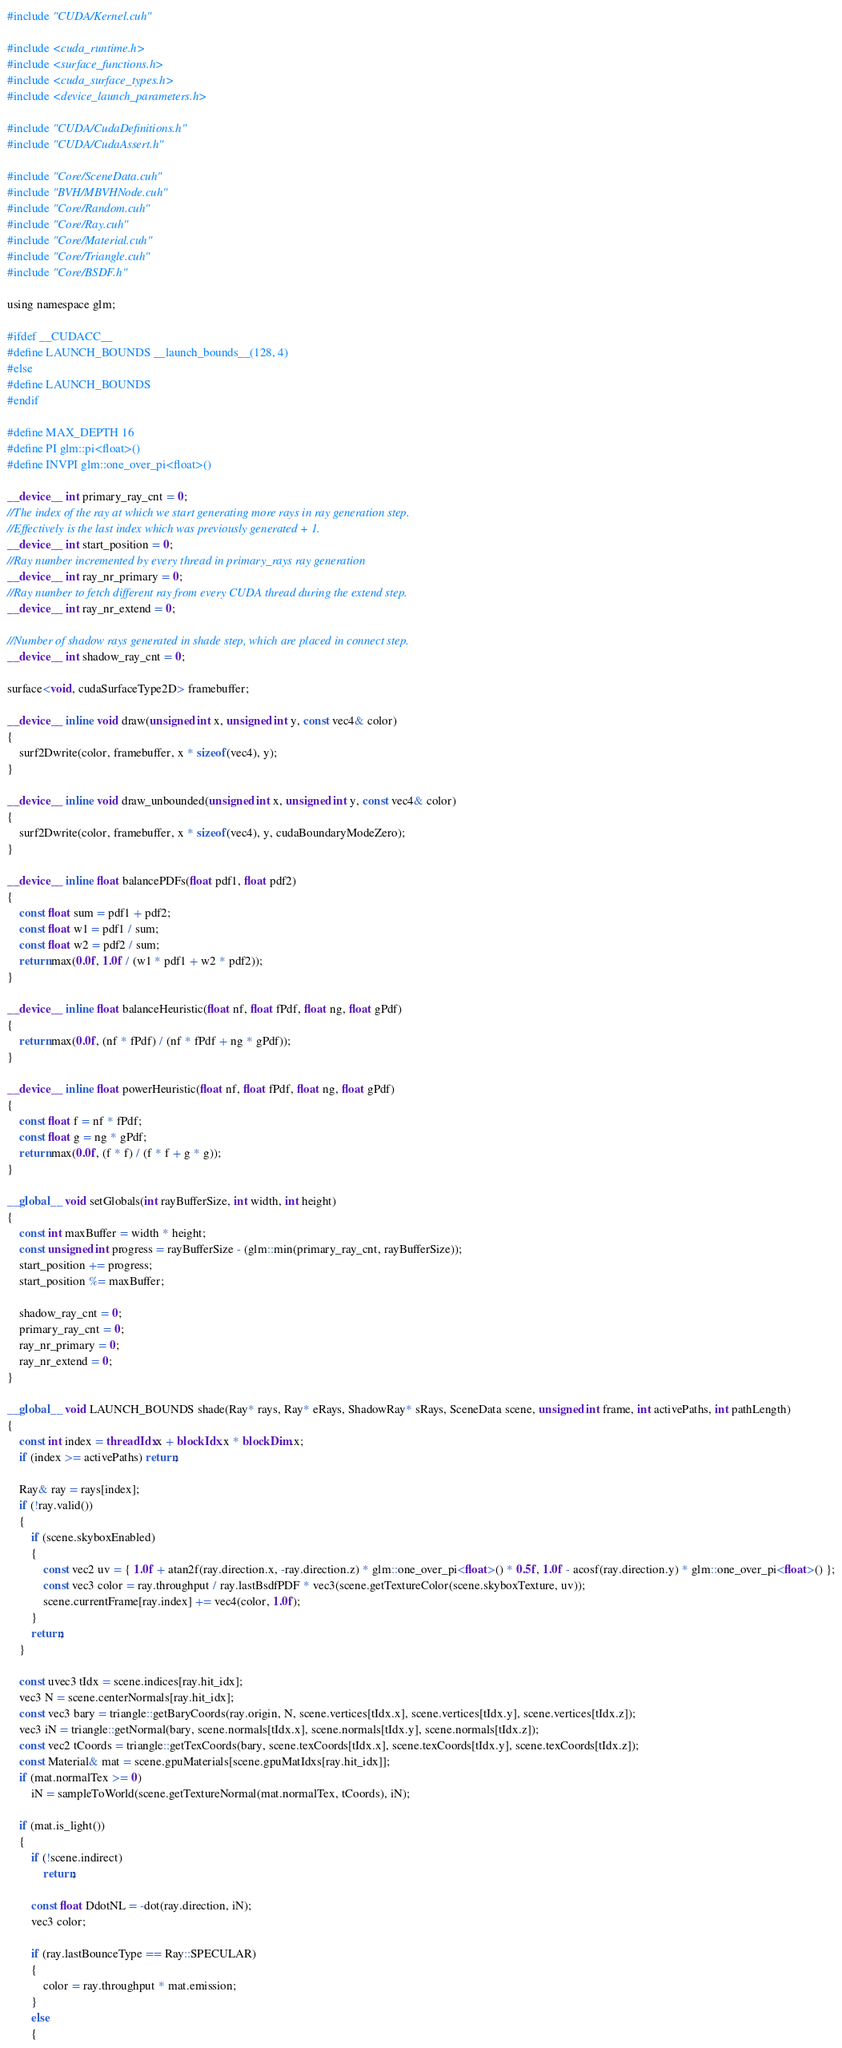Convert code to text. <code><loc_0><loc_0><loc_500><loc_500><_Cuda_>#include "CUDA/Kernel.cuh"

#include <cuda_runtime.h>
#include <surface_functions.h>
#include <cuda_surface_types.h>
#include <device_launch_parameters.h>

#include "CUDA/CudaDefinitions.h"
#include "CUDA/CudaAssert.h"

#include "Core/SceneData.cuh"
#include "BVH/MBVHNode.cuh"
#include "Core/Random.cuh"
#include "Core/Ray.cuh"
#include "Core/Material.cuh"
#include "Core/Triangle.cuh"
#include "Core/BSDF.h"

using namespace glm;

#ifdef __CUDACC__
#define LAUNCH_BOUNDS __launch_bounds__(128, 4)
#else
#define LAUNCH_BOUNDS
#endif

#define MAX_DEPTH 16
#define PI glm::pi<float>()
#define INVPI glm::one_over_pi<float>()

__device__ int primary_ray_cnt = 0;
//The index of the ray at which we start generating more rays in ray generation step.
//Effectively is the last index which was previously generated + 1.
__device__ int start_position = 0;
//Ray number incremented by every thread in primary_rays ray generation
__device__ int ray_nr_primary = 0;
//Ray number to fetch different ray from every CUDA thread during the extend step.
__device__ int ray_nr_extend = 0;

//Number of shadow rays generated in shade step, which are placed in connect step.
__device__ int shadow_ray_cnt = 0;

surface<void, cudaSurfaceType2D> framebuffer;

__device__ inline void draw(unsigned int x, unsigned int y, const vec4& color)
{
	surf2Dwrite(color, framebuffer, x * sizeof(vec4), y);
}

__device__ inline void draw_unbounded(unsigned int x, unsigned int y, const vec4& color)
{
	surf2Dwrite(color, framebuffer, x * sizeof(vec4), y, cudaBoundaryModeZero);
}

__device__ inline float balancePDFs(float pdf1, float pdf2)
{
	const float sum = pdf1 + pdf2;
	const float w1 = pdf1 / sum;
	const float w2 = pdf2 / sum;
	return max(0.0f, 1.0f / (w1 * pdf1 + w2 * pdf2));
}

__device__ inline float balanceHeuristic(float nf, float fPdf, float ng, float gPdf)
{
	return max(0.0f, (nf * fPdf) / (nf * fPdf + ng * gPdf));
}

__device__ inline float powerHeuristic(float nf, float fPdf, float ng, float gPdf)
{
	const float f = nf * fPdf;
	const float g = ng * gPdf;
	return max(0.0f, (f * f) / (f * f + g * g));
}

__global__ void setGlobals(int rayBufferSize, int width, int height)
{
	const int maxBuffer = width * height;
	const unsigned int progress = rayBufferSize - (glm::min(primary_ray_cnt, rayBufferSize));
	start_position += progress;
	start_position %= maxBuffer;

	shadow_ray_cnt = 0;
	primary_ray_cnt = 0;
	ray_nr_primary = 0;
	ray_nr_extend = 0;
}

__global__ void LAUNCH_BOUNDS shade(Ray* rays, Ray* eRays, ShadowRay* sRays, SceneData scene, unsigned int frame, int activePaths, int pathLength)
{
	const int index = threadIdx.x + blockIdx.x * blockDim.x;
	if (index >= activePaths) return;

	Ray& ray = rays[index];
	if (!ray.valid())
	{
		if (scene.skyboxEnabled)
		{
			const vec2 uv = { 1.0f + atan2f(ray.direction.x, -ray.direction.z) * glm::one_over_pi<float>() * 0.5f, 1.0f - acosf(ray.direction.y) * glm::one_over_pi<float>() };
			const vec3 color = ray.throughput / ray.lastBsdfPDF * vec3(scene.getTextureColor(scene.skyboxTexture, uv));
			scene.currentFrame[ray.index] += vec4(color, 1.0f);
		}
		return;
	}

	const uvec3 tIdx = scene.indices[ray.hit_idx];
	vec3 N = scene.centerNormals[ray.hit_idx];
	const vec3 bary = triangle::getBaryCoords(ray.origin, N, scene.vertices[tIdx.x], scene.vertices[tIdx.y], scene.vertices[tIdx.z]);
	vec3 iN = triangle::getNormal(bary, scene.normals[tIdx.x], scene.normals[tIdx.y], scene.normals[tIdx.z]);
	const vec2 tCoords = triangle::getTexCoords(bary, scene.texCoords[tIdx.x], scene.texCoords[tIdx.y], scene.texCoords[tIdx.z]);
	const Material& mat = scene.gpuMaterials[scene.gpuMatIdxs[ray.hit_idx]];
	if (mat.normalTex >= 0)
		iN = sampleToWorld(scene.getTextureNormal(mat.normalTex, tCoords), iN);

	if (mat.is_light())
	{
		if (!scene.indirect)
			return;

		const float DdotNL = -dot(ray.direction, iN);
		vec3 color;

		if (ray.lastBounceType == Ray::SPECULAR)
		{
			color = ray.throughput * mat.emission;
		}
		else
		{</code> 